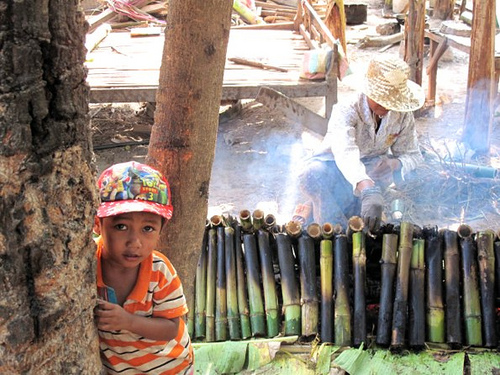<image>
Is the boy behind the tree? Yes. From this viewpoint, the boy is positioned behind the tree, with the tree partially or fully occluding the boy. Is the man on the floor? No. The man is not positioned on the floor. They may be near each other, but the man is not supported by or resting on top of the floor. Is the man on the hat? No. The man is not positioned on the hat. They may be near each other, but the man is not supported by or resting on top of the hat. Is the boy to the right of the trunk? Yes. From this viewpoint, the boy is positioned to the right side relative to the trunk. 